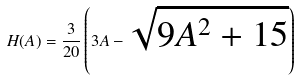Convert formula to latex. <formula><loc_0><loc_0><loc_500><loc_500>H ( A ) = \frac { 3 } { 2 0 } \left ( 3 A - \sqrt { 9 A ^ { 2 } + 1 5 } \right )</formula> 